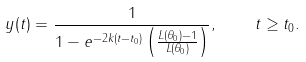Convert formula to latex. <formula><loc_0><loc_0><loc_500><loc_500>y ( t ) = \frac { 1 } { 1 - e ^ { - 2 k ( t - t _ { 0 } ) } \left ( \frac { L ( \theta _ { 0 } ) - 1 } { L ( \theta _ { 0 } ) } \right ) } , \quad t \geq t _ { 0 } .</formula> 